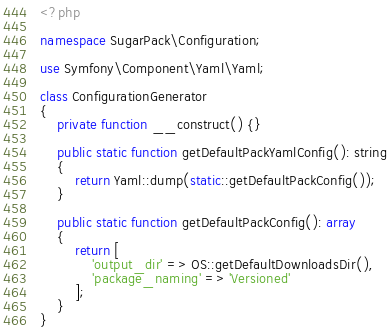<code> <loc_0><loc_0><loc_500><loc_500><_PHP_><?php

namespace SugarPack\Configuration;

use Symfony\Component\Yaml\Yaml;

class ConfigurationGenerator
{
    private function __construct() {}

    public static function getDefaultPackYamlConfig(): string
    {
        return Yaml::dump(static::getDefaultPackConfig());
    }

    public static function getDefaultPackConfig(): array
    {
        return [
            'output_dir' => OS::getDefaultDownloadsDir(),
            'package_naming' => 'Versioned'
        ];
    }
}</code> 